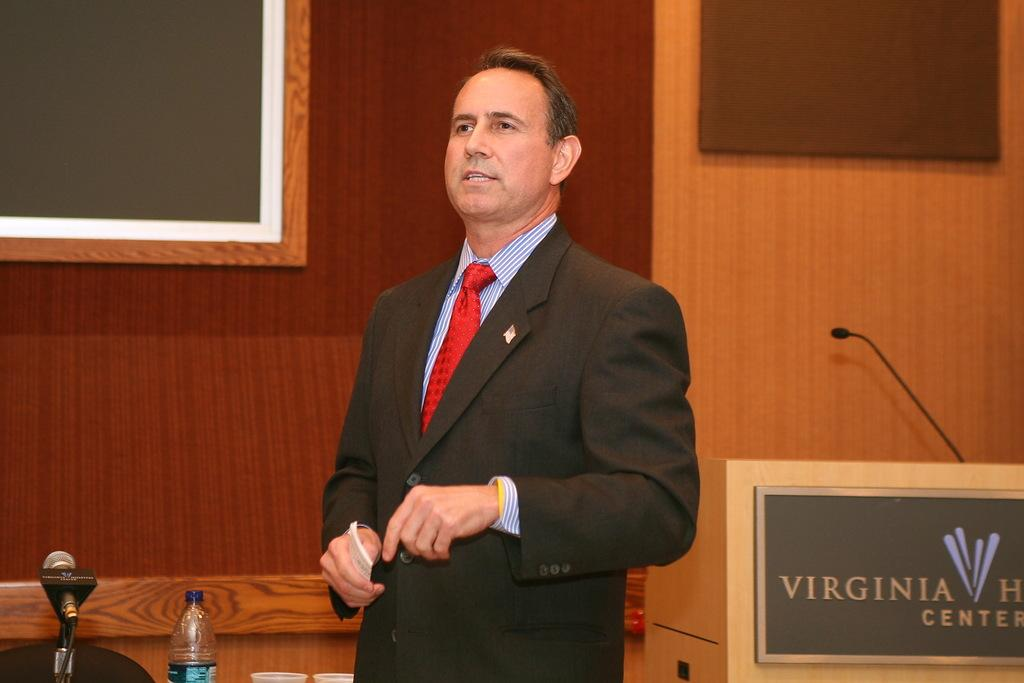<image>
Share a concise interpretation of the image provided. a speaker in a red tie at a virginia health center 